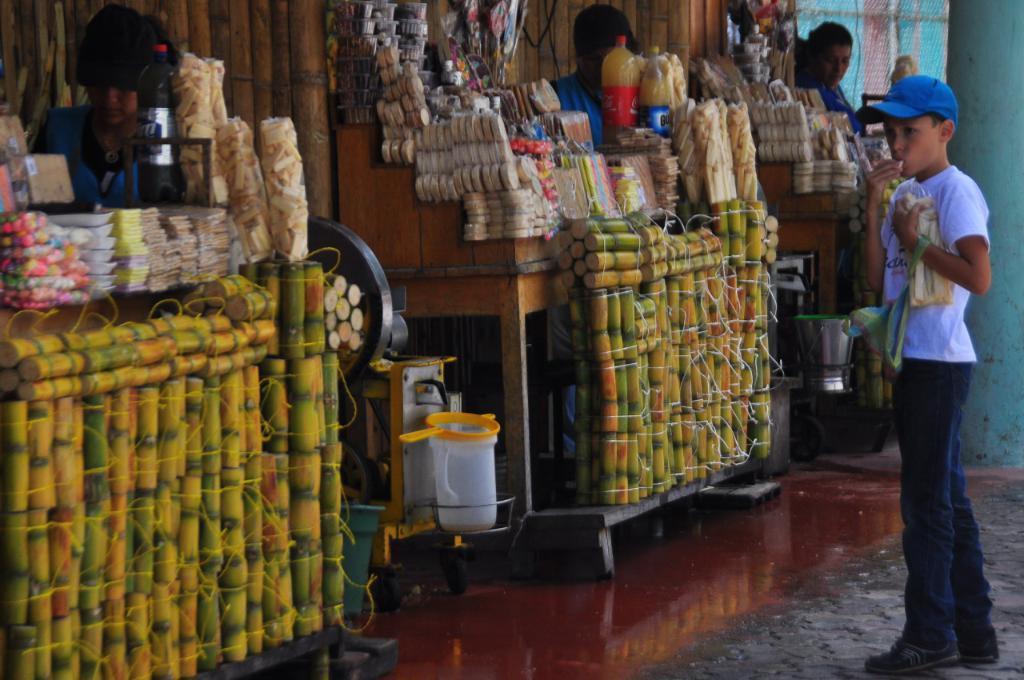Could you give a brief overview of what you see in this image? In this picture we can see a few people. We can see a boy wearing a cap and holding objects in his hands. There is a jug, bucket, bottles, some food items and other objects. 